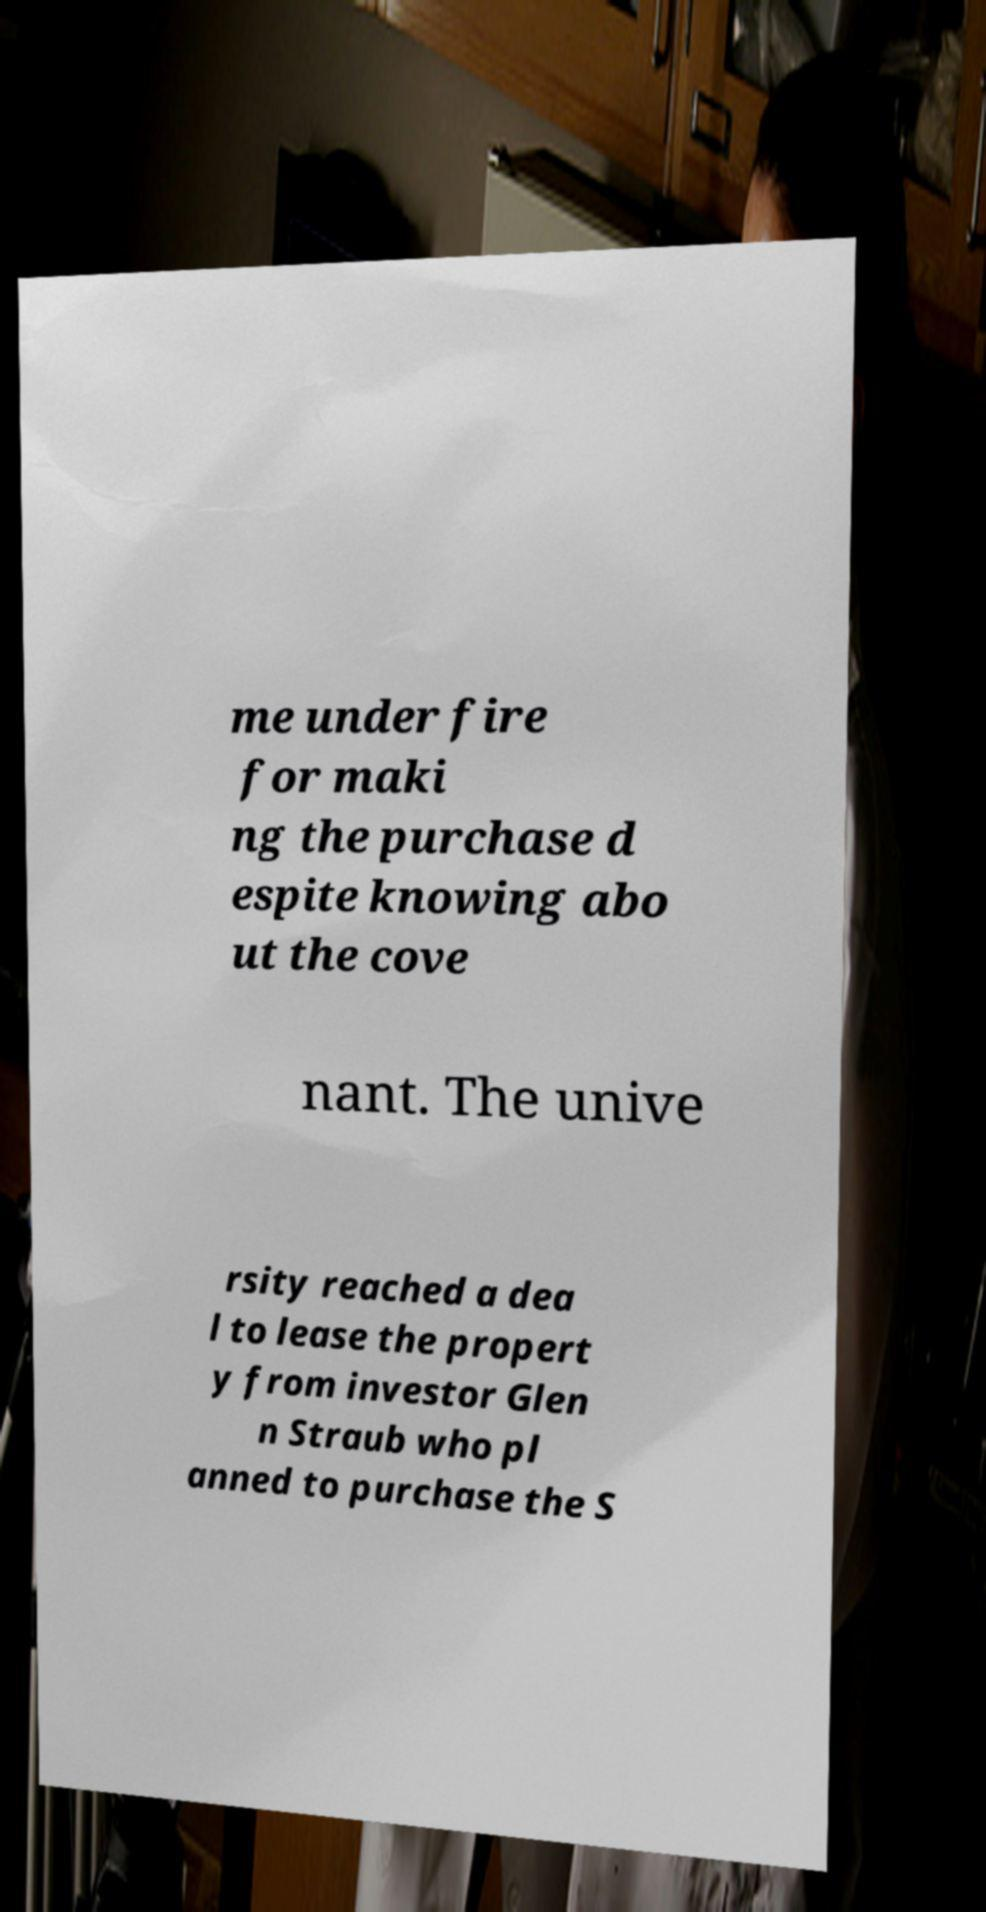I need the written content from this picture converted into text. Can you do that? me under fire for maki ng the purchase d espite knowing abo ut the cove nant. The unive rsity reached a dea l to lease the propert y from investor Glen n Straub who pl anned to purchase the S 